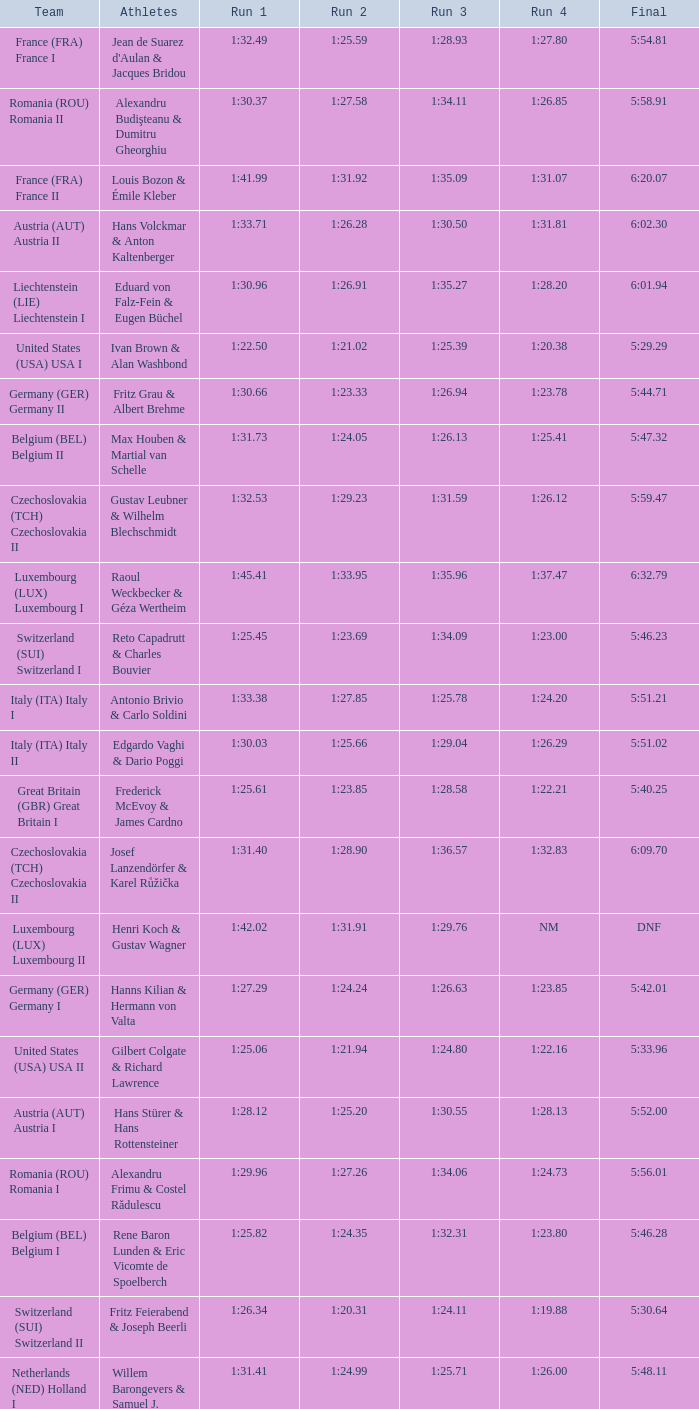Which Final has a Team of liechtenstein (lie) liechtenstein i? 6:01.94. 